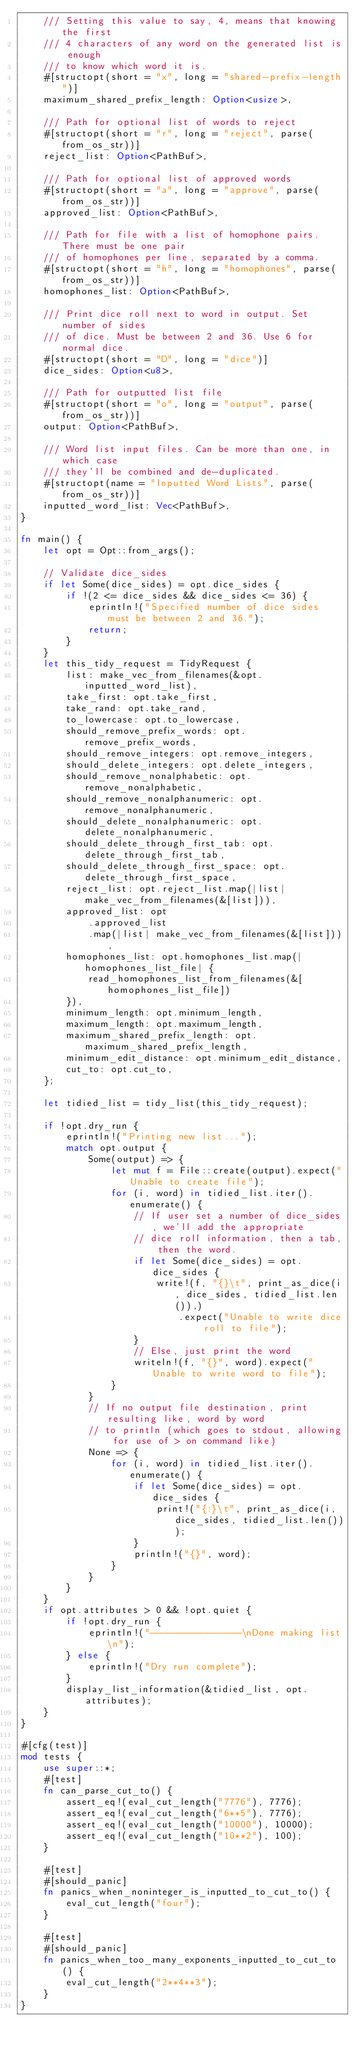<code> <loc_0><loc_0><loc_500><loc_500><_Rust_>    /// Setting this value to say, 4, means that knowing the first
    /// 4 characters of any word on the generated list is enough
    /// to know which word it is.
    #[structopt(short = "x", long = "shared-prefix-length")]
    maximum_shared_prefix_length: Option<usize>,

    /// Path for optional list of words to reject
    #[structopt(short = "r", long = "reject", parse(from_os_str))]
    reject_list: Option<PathBuf>,

    /// Path for optional list of approved words
    #[structopt(short = "a", long = "approve", parse(from_os_str))]
    approved_list: Option<PathBuf>,

    /// Path for file with a list of homophone pairs. There must be one pair
    /// of homophones per line, separated by a comma.
    #[structopt(short = "h", long = "homophones", parse(from_os_str))]
    homophones_list: Option<PathBuf>,

    /// Print dice roll next to word in output. Set number of sides
    /// of dice. Must be between 2 and 36. Use 6 for normal dice.
    #[structopt(short = "D", long = "dice")]
    dice_sides: Option<u8>,

    /// Path for outputted list file
    #[structopt(short = "o", long = "output", parse(from_os_str))]
    output: Option<PathBuf>,

    /// Word list input files. Can be more than one, in which case
    /// they'll be combined and de-duplicated.
    #[structopt(name = "Inputted Word Lists", parse(from_os_str))]
    inputted_word_list: Vec<PathBuf>,
}

fn main() {
    let opt = Opt::from_args();

    // Validate dice_sides
    if let Some(dice_sides) = opt.dice_sides {
        if !(2 <= dice_sides && dice_sides <= 36) {
            eprintln!("Specified number of dice sides must be between 2 and 36.");
            return;
        }
    }
    let this_tidy_request = TidyRequest {
        list: make_vec_from_filenames(&opt.inputted_word_list),
        take_first: opt.take_first,
        take_rand: opt.take_rand,
        to_lowercase: opt.to_lowercase,
        should_remove_prefix_words: opt.remove_prefix_words,
        should_remove_integers: opt.remove_integers,
        should_delete_integers: opt.delete_integers,
        should_remove_nonalphabetic: opt.remove_nonalphabetic,
        should_remove_nonalphanumeric: opt.remove_nonalphanumeric,
        should_delete_nonalphanumeric: opt.delete_nonalphanumeric,
        should_delete_through_first_tab: opt.delete_through_first_tab,
        should_delete_through_first_space: opt.delete_through_first_space,
        reject_list: opt.reject_list.map(|list| make_vec_from_filenames(&[list])),
        approved_list: opt
            .approved_list
            .map(|list| make_vec_from_filenames(&[list])),
        homophones_list: opt.homophones_list.map(|homophones_list_file| {
            read_homophones_list_from_filenames(&[homophones_list_file])
        }),
        minimum_length: opt.minimum_length,
        maximum_length: opt.maximum_length,
        maximum_shared_prefix_length: opt.maximum_shared_prefix_length,
        minimum_edit_distance: opt.minimum_edit_distance,
        cut_to: opt.cut_to,
    };

    let tidied_list = tidy_list(this_tidy_request);

    if !opt.dry_run {
        eprintln!("Printing new list...");
        match opt.output {
            Some(output) => {
                let mut f = File::create(output).expect("Unable to create file");
                for (i, word) in tidied_list.iter().enumerate() {
                    // If user set a number of dice_sides, we'll add the appropriate
                    // dice roll information, then a tab, then the word.
                    if let Some(dice_sides) = opt.dice_sides {
                        write!(f, "{}\t", print_as_dice(i, dice_sides, tidied_list.len()),)
                            .expect("Unable to write dice roll to file");
                    }
                    // Else, just print the word
                    writeln!(f, "{}", word).expect("Unable to write word to file");
                }
            }
            // If no output file destination, print resulting like, word by word
            // to println (which goes to stdout, allowing for use of > on command like)
            None => {
                for (i, word) in tidied_list.iter().enumerate() {
                    if let Some(dice_sides) = opt.dice_sides {
                        print!("{:}\t", print_as_dice(i, dice_sides, tidied_list.len()));
                    }
                    println!("{}", word);
                }
            }
        }
    }
    if opt.attributes > 0 && !opt.quiet {
        if !opt.dry_run {
            eprintln!("----------------\nDone making list\n");
        } else {
            eprintln!("Dry run complete");
        }
        display_list_information(&tidied_list, opt.attributes);
    }
}

#[cfg(test)]
mod tests {
    use super::*;
    #[test]
    fn can_parse_cut_to() {
        assert_eq!(eval_cut_length("7776"), 7776);
        assert_eq!(eval_cut_length("6**5"), 7776);
        assert_eq!(eval_cut_length("10000"), 10000);
        assert_eq!(eval_cut_length("10**2"), 100);
    }

    #[test]
    #[should_panic]
    fn panics_when_noninteger_is_inputted_to_cut_to() {
        eval_cut_length("four");
    }

    #[test]
    #[should_panic]
    fn panics_when_too_many_exponents_inputted_to_cut_to() {
        eval_cut_length("2**4**3");
    }
}
</code> 